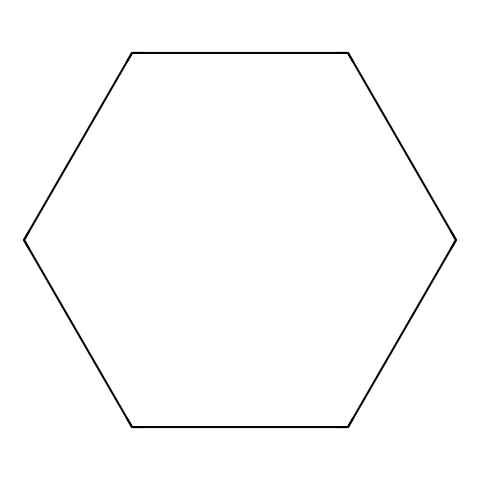What is the molecular formula of cyclohexane? The structure of cyclohexane consists of six carbon atoms and twelve hydrogen atoms. Counting the carbon atoms gives us 'C6' and counting the hydrogen atoms gives us 'H12'. Therefore, the molecular formula is C6H12.
Answer: C6H12 How many carbon atoms are present in cyclohexane? The chemical structure displays a total of six carbon atoms arranged in a cycle. Each vertex of the hexagonal shape represents a carbon atom, which totals to six.
Answer: six What type of bonding is present in cyclohexane? The structure indicates that cyclohexane is fully saturated, meaning it contains single bonds between carbon atoms. Since all the connections are single bonds (sigma bonds), the type of bonding is covalent.
Answer: covalent What is the degree of unsaturation in cyclohexane? The degree of unsaturation can be calculated using the formula: (2C + 2 - H)/2. For cyclohexane (C6H12), this results in (2*6 + 2 - 12)/2 = 0. This indicates that cyclohexane is fully saturated with no rings or double bonds contributing to unsaturation.
Answer: 0 Is cyclohexane a polar or nonpolar molecule? Cyclohexane is a nonpolar molecule because it is composed entirely of carbon and hydrogen atoms arranged in a symmetrical ring structure. This symmetry results in an even distribution of charge, which characterizes nonpolar substances.
Answer: nonpolar What is the hybridization of the carbon atoms in cyclohexane? In cyclohexane, each carbon atom is bonded to two other carbons and two hydrogens. This leads to sp3 hybridization, as each carbon forms four single bonds in a tetrahedral arrangement. Therefore, the hybridization of the carbon atoms is sp3.
Answer: sp3 